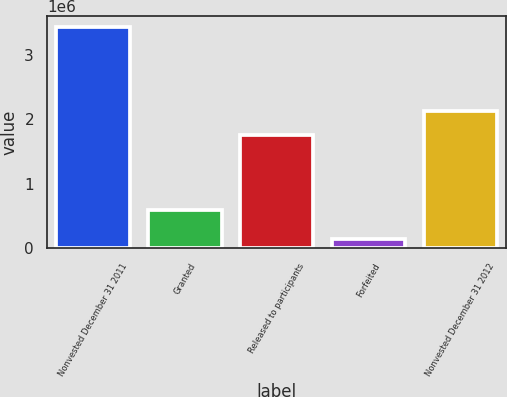Convert chart to OTSL. <chart><loc_0><loc_0><loc_500><loc_500><bar_chart><fcel>Nonvested December 31 2011<fcel>Granted<fcel>Released to participants<fcel>Forfeited<fcel>Nonvested December 31 2012<nl><fcel>3.43232e+06<fcel>600750<fcel>1.75565e+06<fcel>144261<fcel>2.13316e+06<nl></chart> 